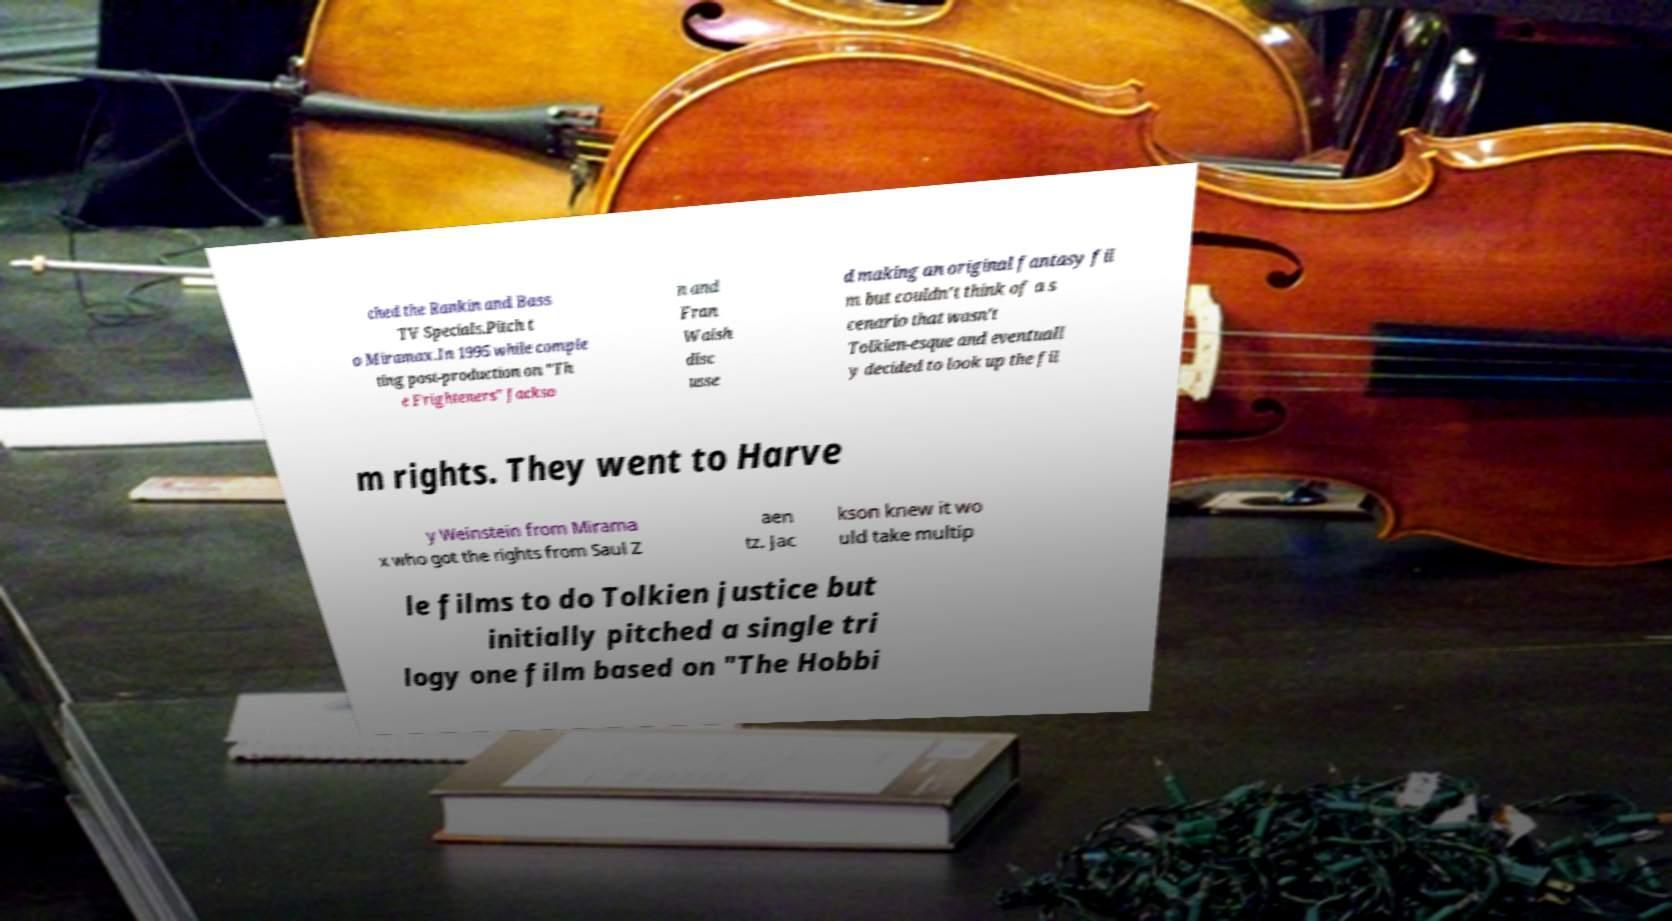What messages or text are displayed in this image? I need them in a readable, typed format. ched the Rankin and Bass TV Specials.Pitch t o Miramax.In 1995 while comple ting post-production on "Th e Frighteners" Jackso n and Fran Walsh disc usse d making an original fantasy fil m but couldn't think of a s cenario that wasn't Tolkien-esque and eventuall y decided to look up the fil m rights. They went to Harve y Weinstein from Mirama x who got the rights from Saul Z aen tz. Jac kson knew it wo uld take multip le films to do Tolkien justice but initially pitched a single tri logy one film based on "The Hobbi 